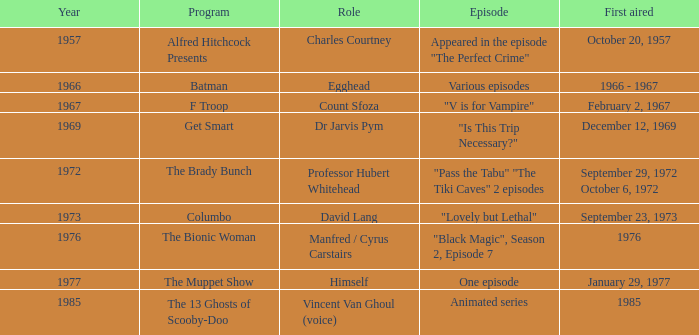What's the debut airing date when professor hubert whitehead assumed the role? September 29, 1972 October 6, 1972. 